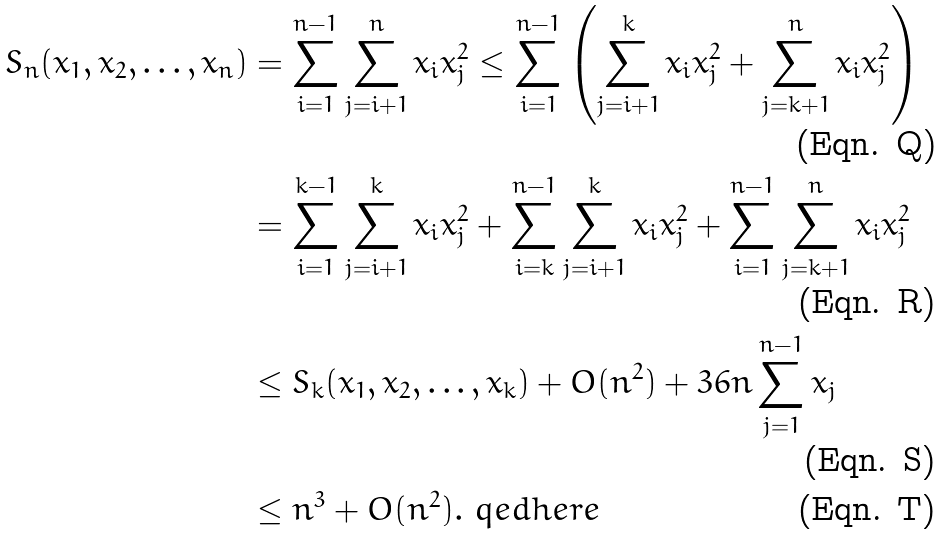Convert formula to latex. <formula><loc_0><loc_0><loc_500><loc_500>S _ { n } ( x _ { 1 } , x _ { 2 } , \dots , x _ { n } ) & = \sum _ { i = 1 } ^ { n - 1 } \sum _ { j = i + 1 } ^ { n } x _ { i } x _ { j } ^ { 2 } \leq \sum _ { i = 1 } ^ { n - 1 } \left ( \sum _ { j = i + 1 } ^ { k } x _ { i } x _ { j } ^ { 2 } + \sum _ { j = k + 1 } ^ { n } x _ { i } x _ { j } ^ { 2 } \right ) \\ & = \sum _ { i = 1 } ^ { k - 1 } \sum _ { j = i + 1 } ^ { k } x _ { i } x _ { j } ^ { 2 } + \sum _ { i = k } ^ { n - 1 } \sum _ { j = i + 1 } ^ { k } x _ { i } x _ { j } ^ { 2 } + \sum _ { i = 1 } ^ { n - 1 } \sum _ { j = k + 1 } ^ { n } x _ { i } x _ { j } ^ { 2 } \\ & \leq S _ { k } ( x _ { 1 } , x _ { 2 } , \dots , x _ { k } ) + O ( n ^ { 2 } ) + 3 6 n \sum _ { j = 1 } ^ { n - 1 } x _ { j } \\ & \leq n ^ { 3 } + O ( n ^ { 2 } ) . \ q e d h e r e</formula> 